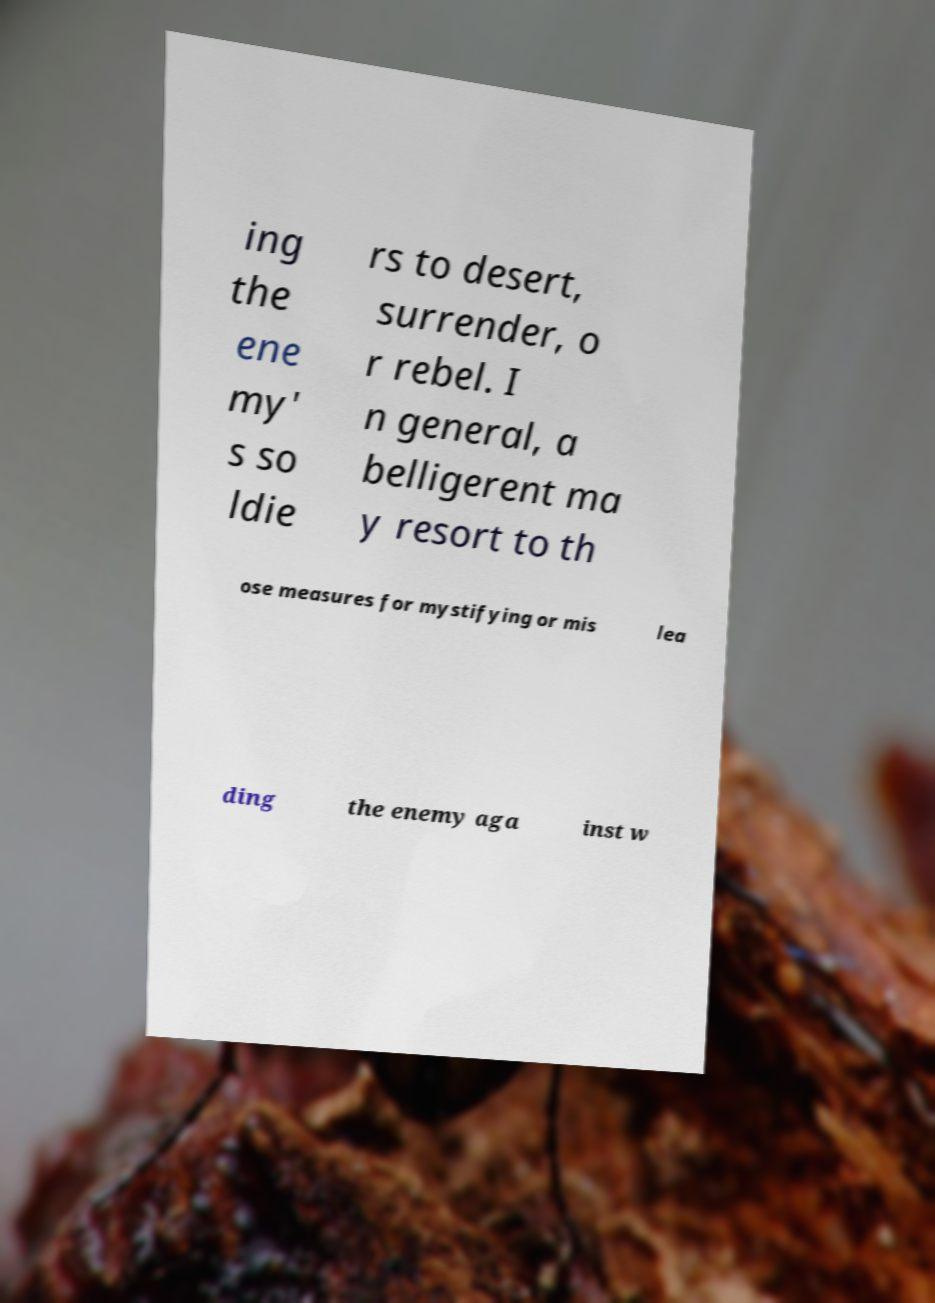Please identify and transcribe the text found in this image. ing the ene my' s so ldie rs to desert, surrender, o r rebel. I n general, a belligerent ma y resort to th ose measures for mystifying or mis lea ding the enemy aga inst w 